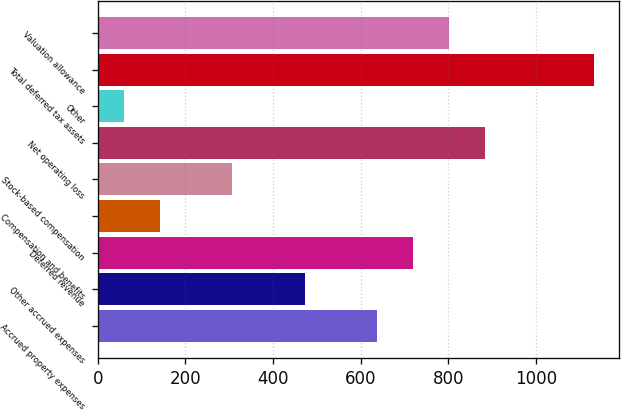Convert chart. <chart><loc_0><loc_0><loc_500><loc_500><bar_chart><fcel>Accrued property expenses<fcel>Other accrued expenses<fcel>Deferred revenue<fcel>Compensation and benefits<fcel>Stock-based compensation<fcel>Net operating loss<fcel>Other<fcel>Total deferred tax assets<fcel>Valuation allowance<nl><fcel>637.5<fcel>472.5<fcel>720<fcel>142.5<fcel>307.5<fcel>885<fcel>60<fcel>1132.5<fcel>802.5<nl></chart> 